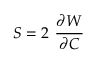<formula> <loc_0><loc_0><loc_500><loc_500>{ S } = 2 { \cfrac { \partial W } { \partial { C } } }</formula> 